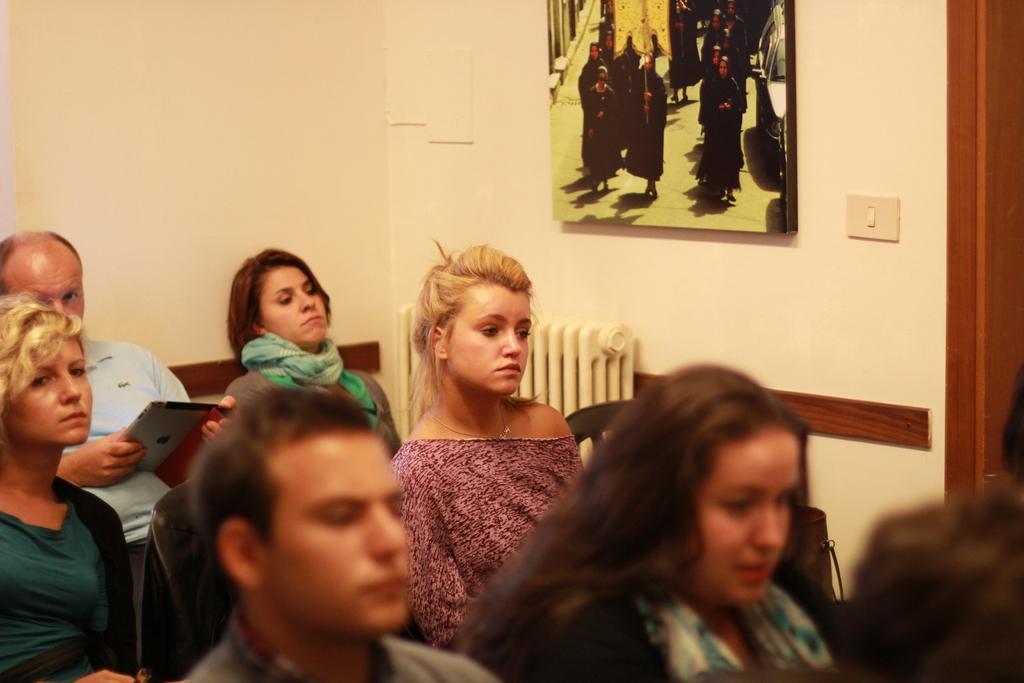Describe this image in one or two sentences. In this image, in the middle there is a woman, she is sitting. At the bottom there are people, they are sitting. On the right there is a woman, she is sitting. In the middle there is a man and a woman, they are sitting. In the background there are chairs, photo frame, switch board and a wall. 